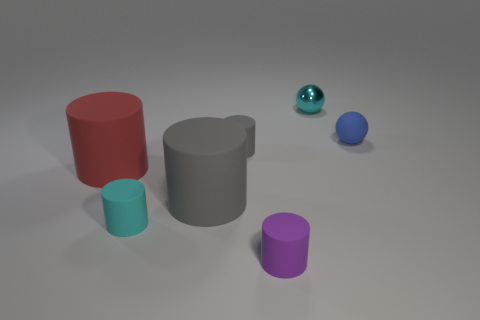Subtract all cyan cylinders. How many cylinders are left? 4 Subtract all purple cylinders. How many cylinders are left? 4 Subtract all blue cylinders. Subtract all gray balls. How many cylinders are left? 5 Add 2 big red matte objects. How many objects exist? 9 Subtract all spheres. How many objects are left? 5 Add 3 yellow matte cylinders. How many yellow matte cylinders exist? 3 Subtract 0 red blocks. How many objects are left? 7 Subtract all large brown rubber objects. Subtract all rubber things. How many objects are left? 1 Add 5 cyan objects. How many cyan objects are left? 7 